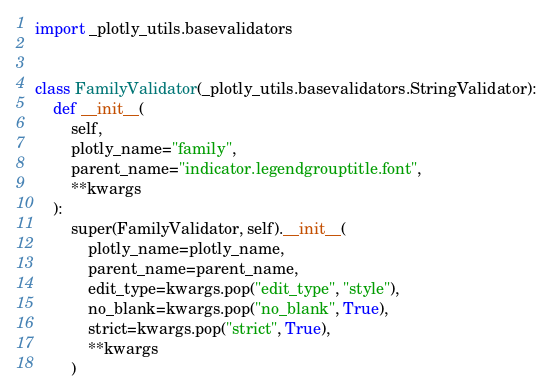<code> <loc_0><loc_0><loc_500><loc_500><_Python_>import _plotly_utils.basevalidators


class FamilyValidator(_plotly_utils.basevalidators.StringValidator):
    def __init__(
        self,
        plotly_name="family",
        parent_name="indicator.legendgrouptitle.font",
        **kwargs
    ):
        super(FamilyValidator, self).__init__(
            plotly_name=plotly_name,
            parent_name=parent_name,
            edit_type=kwargs.pop("edit_type", "style"),
            no_blank=kwargs.pop("no_blank", True),
            strict=kwargs.pop("strict", True),
            **kwargs
        )
</code> 